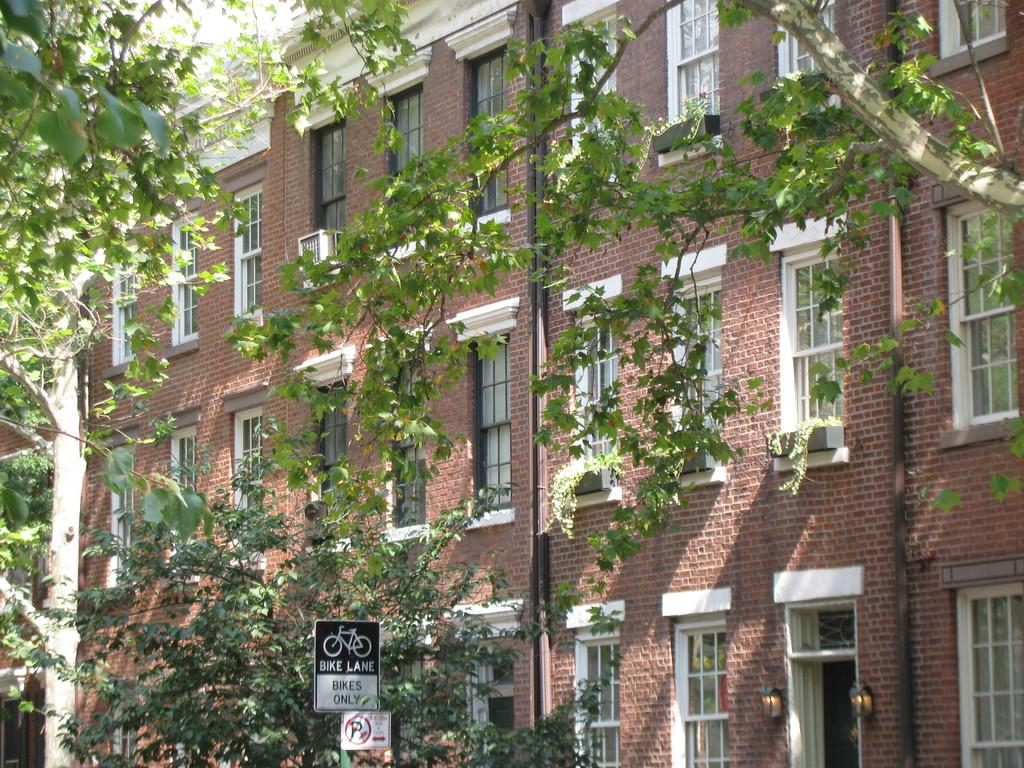What type of structures can be seen in the image? There are buildings in the image. What other natural elements are present in the image? There are trees in the image. Is there any text or information displayed in the image? Yes, there is a sign board in the image. What feature can be seen on the buildings in the image? There are windows in the image. Can you see any fowl or dinosaurs in the image? No, there are no fowl or dinosaurs present in the image. What type of grain can be seen growing in the image? There is no grain visible in the image. 